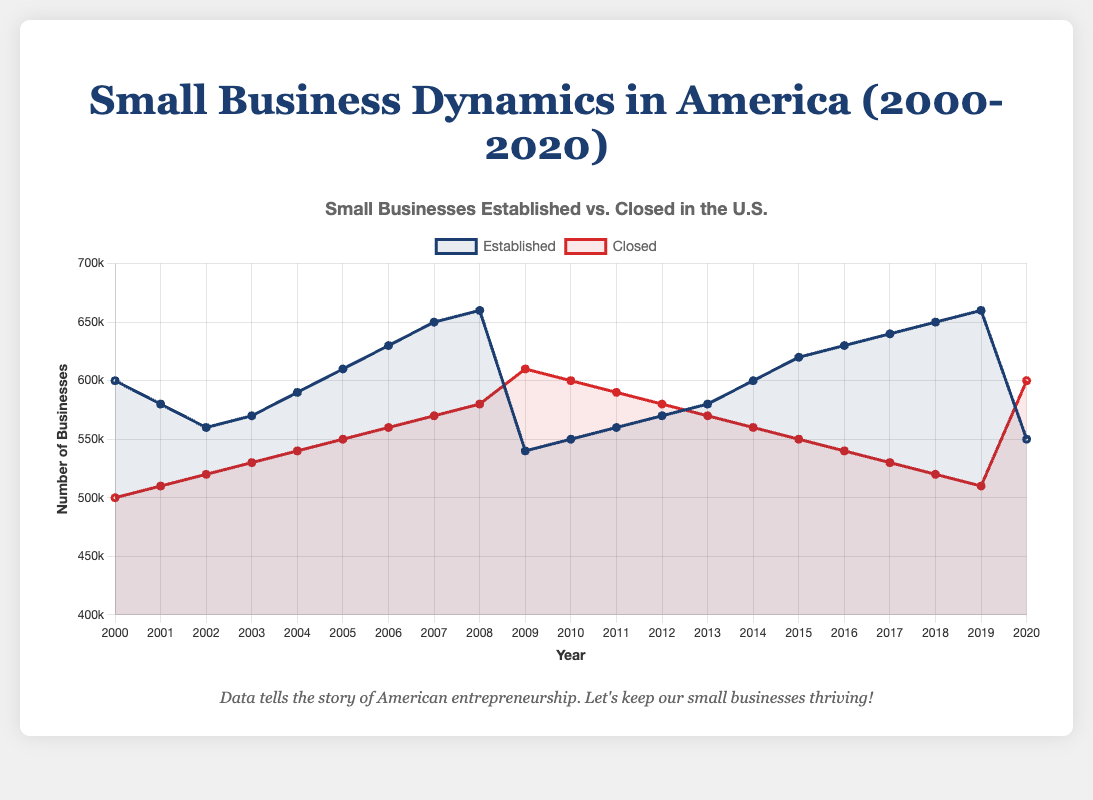What was the gap between the number of businesses established and closed in 2009? To determine the gap, subtract the number of businesses closed (610,000) from the number of businesses established (540,000). So, 540,000 - 610,000 = -70,000.
Answer: -70,000 Which year had the highest number of small businesses established? By observing the "Established" lines on the chart, 2019 shows the highest point at 660,000.
Answer: 2019 In what year did the number of businesses closed equal the number established? By looking at the chart, no two lines touch or intersect each other, implying there is no year where the number of established businesses equals the number of closed businesses.
Answer: None What is the overall trend for the number of businesses established between 2000 and 2020? The chart trends upwards until 2019, then drops sharply in 2020.
Answer: Upward until 2019, then sharp drop Which year showed the most significant increase in business closures? The largest gap on the "Closed" line appears between 2008 and 2009, rising from 580,000 to 610,000.
Answer: 2008 to 2009 Describe the relationship between the number of businesses established and closed in 2020 In 2020, the number of businesses closed (600,000) exceeds the number of businesses established (550,000).
Answer: Closed exceeds Established How does the number of businesses closed in 2010 compare to that in 2000? The number closed in 2010 (600,000) is higher than in 2000 (500,000) by 100,000.
Answer: Higher by 100,000 What general trend can be observed in the number of businesses closed from 2000 to 2019? There is an overall upward trend until 2009, followed by a steady decline through 2019.
Answer: Upward until 2009, then downward 